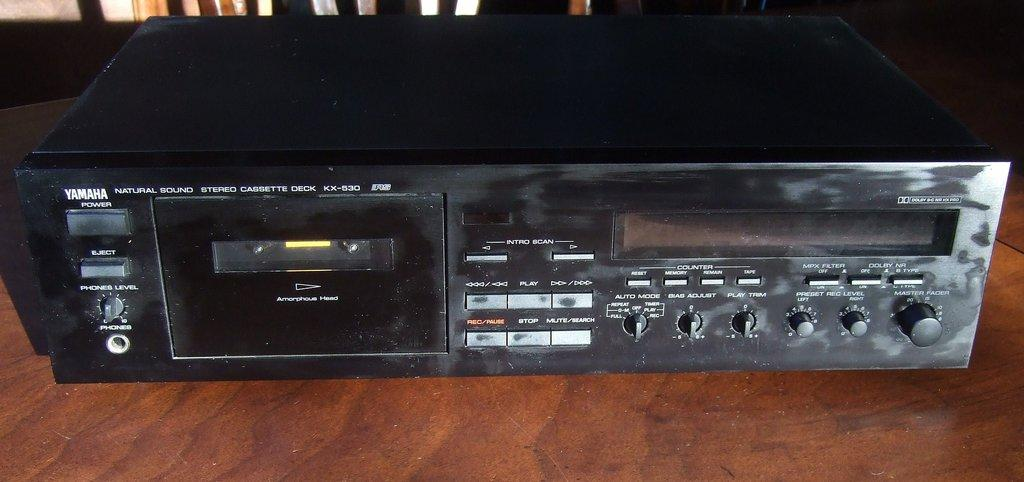What type of electronic device is present in the image? There is an amplifier in the image. What color is the amplifier? The amplifier is black in color. Where is the amplifier located in the image? The amplifier is on a table. How many geese are sitting on the sink in the image? There are no geese or sink present in the image. 